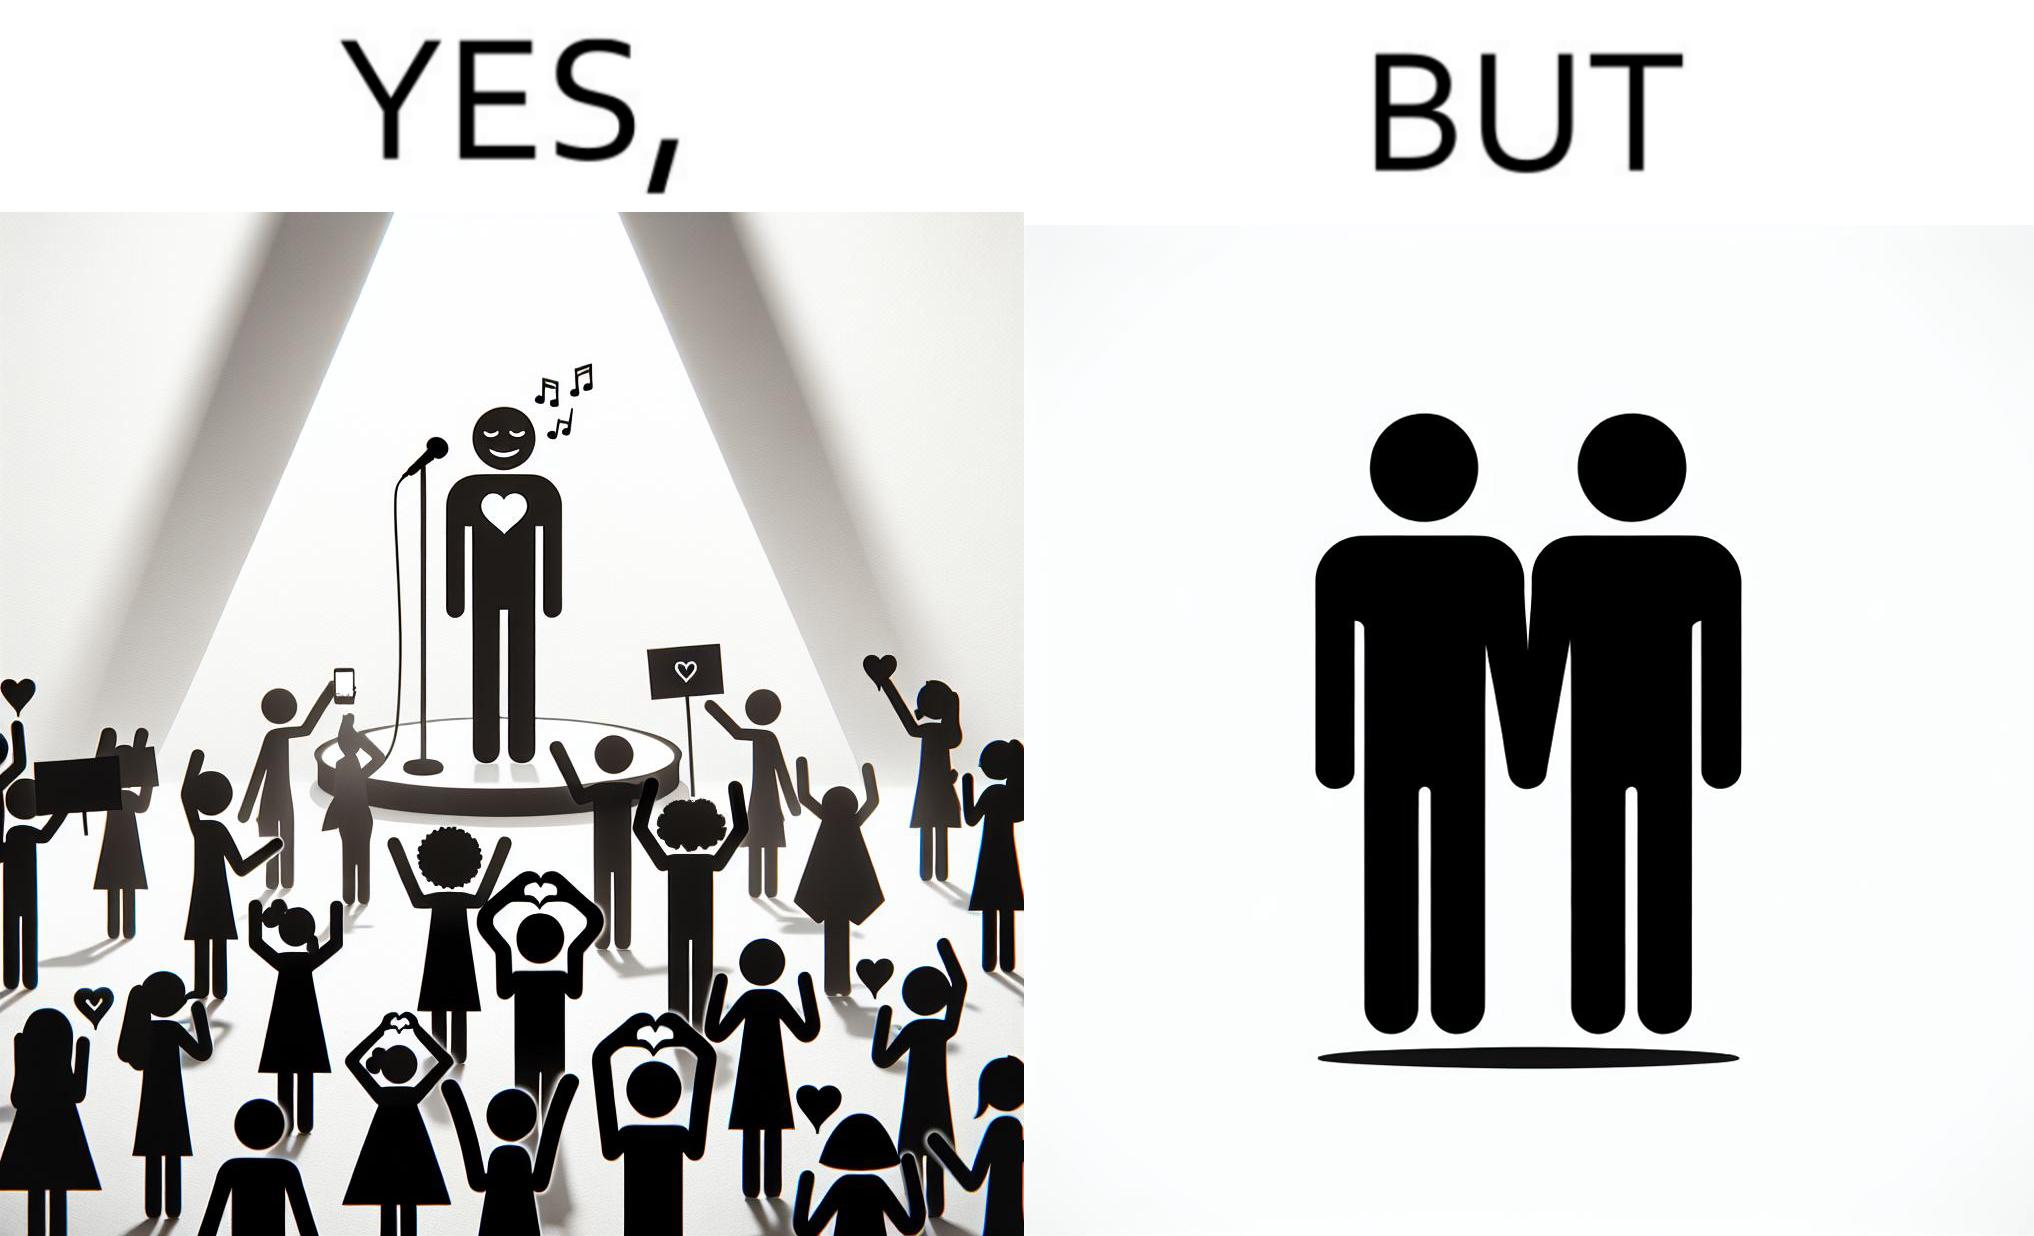Compare the left and right sides of this image. In the left part of the image: The person shows a man singing on a platform under a spotlight. There are several girls around the platform enjoying his singing and cheering for him. A few girls are taking his photos using their phone and a few also have a poster with heart drawn on it. In the right part of the image: The image shows two men holding hands. 